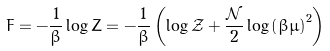Convert formula to latex. <formula><loc_0><loc_0><loc_500><loc_500>F = - \frac { 1 } { \beta } \log Z = - \frac { 1 } { \beta } \left ( \log \mathcal { Z } + \frac { \mathcal { N } } { 2 } \log \left ( \beta \mu \right ) ^ { 2 } \right )</formula> 